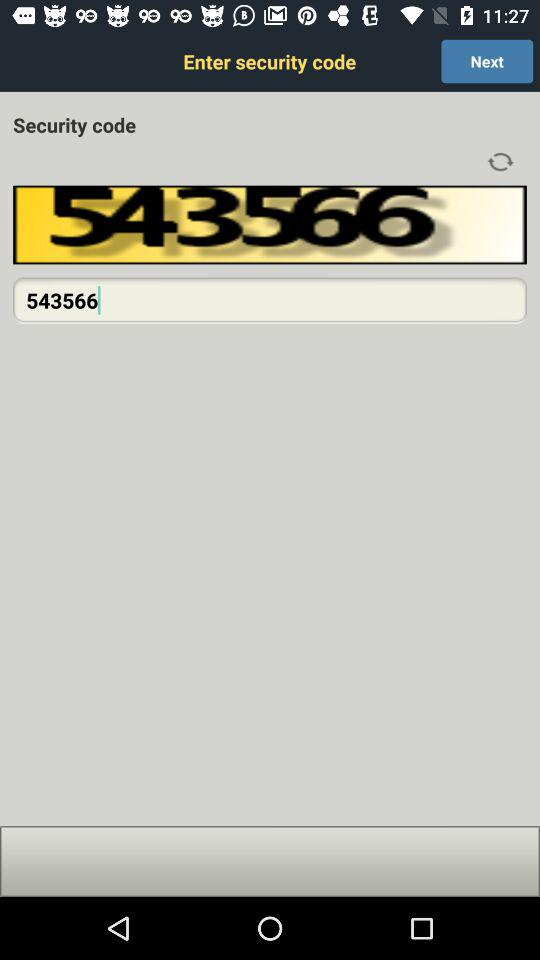What is the security code? The security code is 543566. 